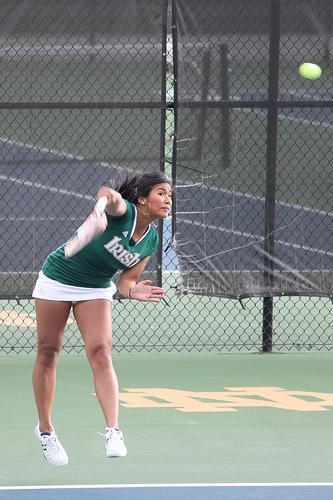How many people are in the picture?
Give a very brief answer. 1. 